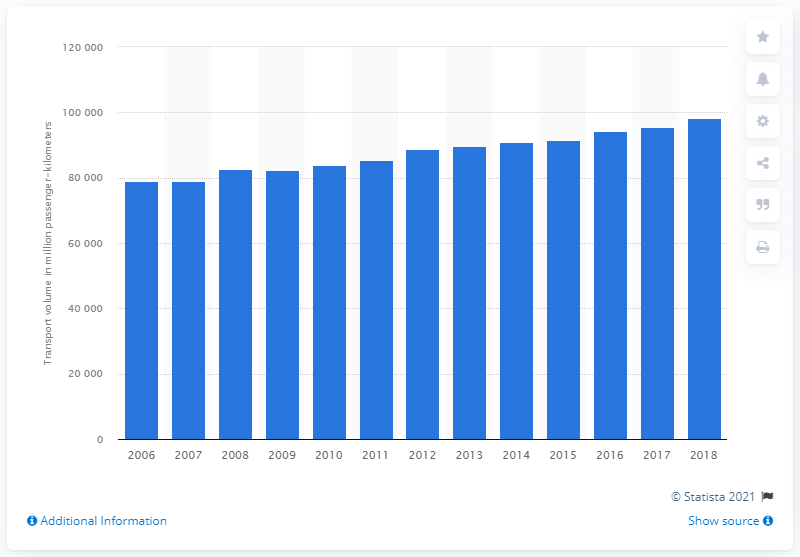Identify some key points in this picture. In 2018, the volume of passenger rail transport in Germany was 98,161 units. 